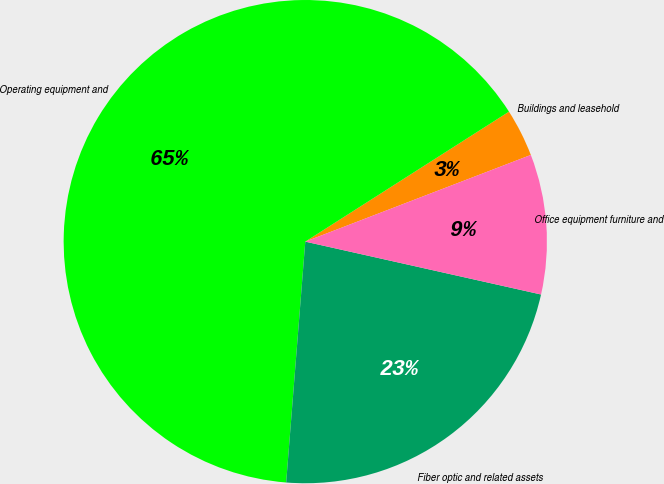Convert chart to OTSL. <chart><loc_0><loc_0><loc_500><loc_500><pie_chart><fcel>Buildings and leasehold<fcel>Operating equipment and<fcel>Fiber optic and related assets<fcel>Office equipment furniture and<nl><fcel>3.2%<fcel>64.7%<fcel>22.75%<fcel>9.35%<nl></chart> 